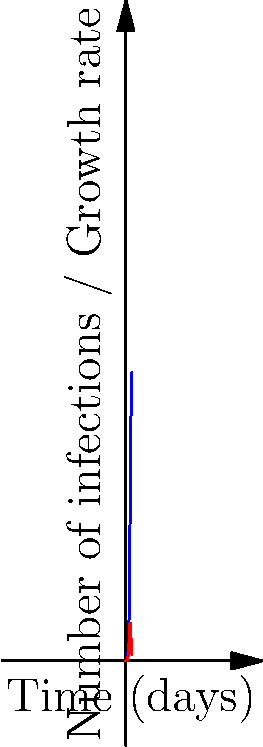You've developed a new strain of malware that spreads according to the logistic function $P(t) = \frac{1000}{1 + 999e^{-0.5t}}$, where $P(t)$ is the number of infected systems at time $t$ (in days). At what time $t$ does the malware infection reach its maximum growth rate, and what is this maximum rate? To find the maximum growth rate and when it occurs, we need to follow these steps:

1) The growth rate is given by the derivative of $P(t)$. Let's call this $P'(t)$.

2) $P'(t) = \frac{1000 \cdot 0.5 \cdot 999e^{-0.5t}}{(1 + 999e^{-0.5t})^2}$

3) To find the maximum of $P'(t)$, we need to find where its derivative equals zero. Let's call this second derivative $P''(t)$.

4) $P''(t) = \frac{1000 \cdot 0.5 \cdot 999e^{-0.5t} \cdot (-0.5) \cdot (1 + 999e^{-0.5t})^2 - 2 \cdot 1000 \cdot 0.5 \cdot 999e^{-0.5t} \cdot (1 + 999e^{-0.5t}) \cdot (-0.5 \cdot 999e^{-0.5t})}{(1 + 999e^{-0.5t})^4}$

5) Setting $P''(t) = 0$ and solving for $t$ gives us:

   $t = \frac{2\ln(999)}{0.5} = 4\ln(999) \approx 27.63$ days

6) To find the maximum growth rate, we substitute this $t$ value back into $P'(t)$:

   $P'(27.63) = \frac{1000 \cdot 0.5 \cdot 999e^{-0.5 \cdot 27.63}}{(1 + 999e^{-0.5 \cdot 27.63})^2} \approx 125$ infections per day

Therefore, the maximum growth rate occurs at approximately 27.63 days and is about 125 new infections per day.
Answer: $t \approx 27.63$ days, Maximum rate $\approx 125$ infections/day 